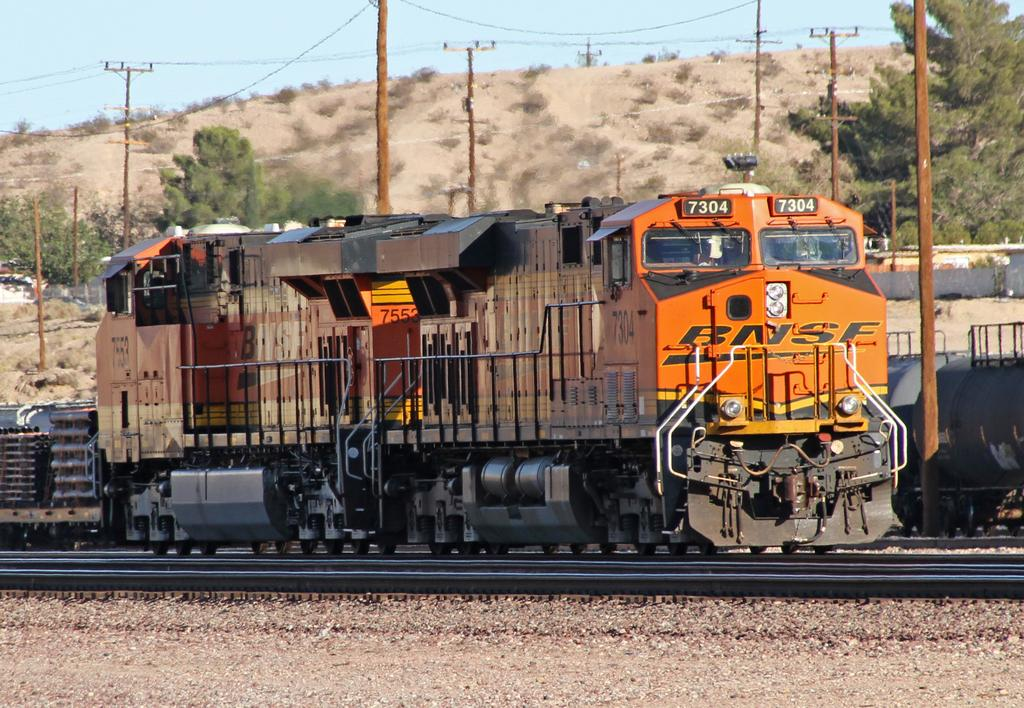What type of vehicles can be seen on the track in the image? There are trains on the track in the image. What structures are near the trains? There are many poles near the trains. What can be seen in the background of the image? Trees, mountains, and the sky are visible in the background. How many poles are visible in the image? There are more poles visible in the background as well. What type of honey is being sold at the train station in the image? There is no mention of honey or a train station in the image; it features trains on a track with poles and a background of trees, mountains, and the sky. 